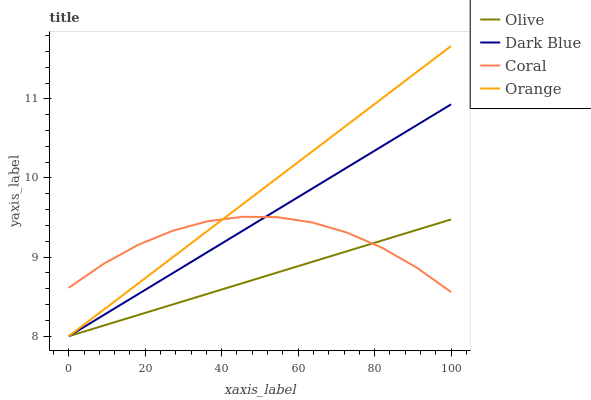Does Olive have the minimum area under the curve?
Answer yes or no. Yes. Does Orange have the maximum area under the curve?
Answer yes or no. Yes. Does Dark Blue have the minimum area under the curve?
Answer yes or no. No. Does Dark Blue have the maximum area under the curve?
Answer yes or no. No. Is Orange the smoothest?
Answer yes or no. Yes. Is Coral the roughest?
Answer yes or no. Yes. Is Dark Blue the smoothest?
Answer yes or no. No. Is Dark Blue the roughest?
Answer yes or no. No. Does Coral have the lowest value?
Answer yes or no. No. Does Orange have the highest value?
Answer yes or no. Yes. Does Dark Blue have the highest value?
Answer yes or no. No. Does Orange intersect Dark Blue?
Answer yes or no. Yes. Is Orange less than Dark Blue?
Answer yes or no. No. Is Orange greater than Dark Blue?
Answer yes or no. No. 